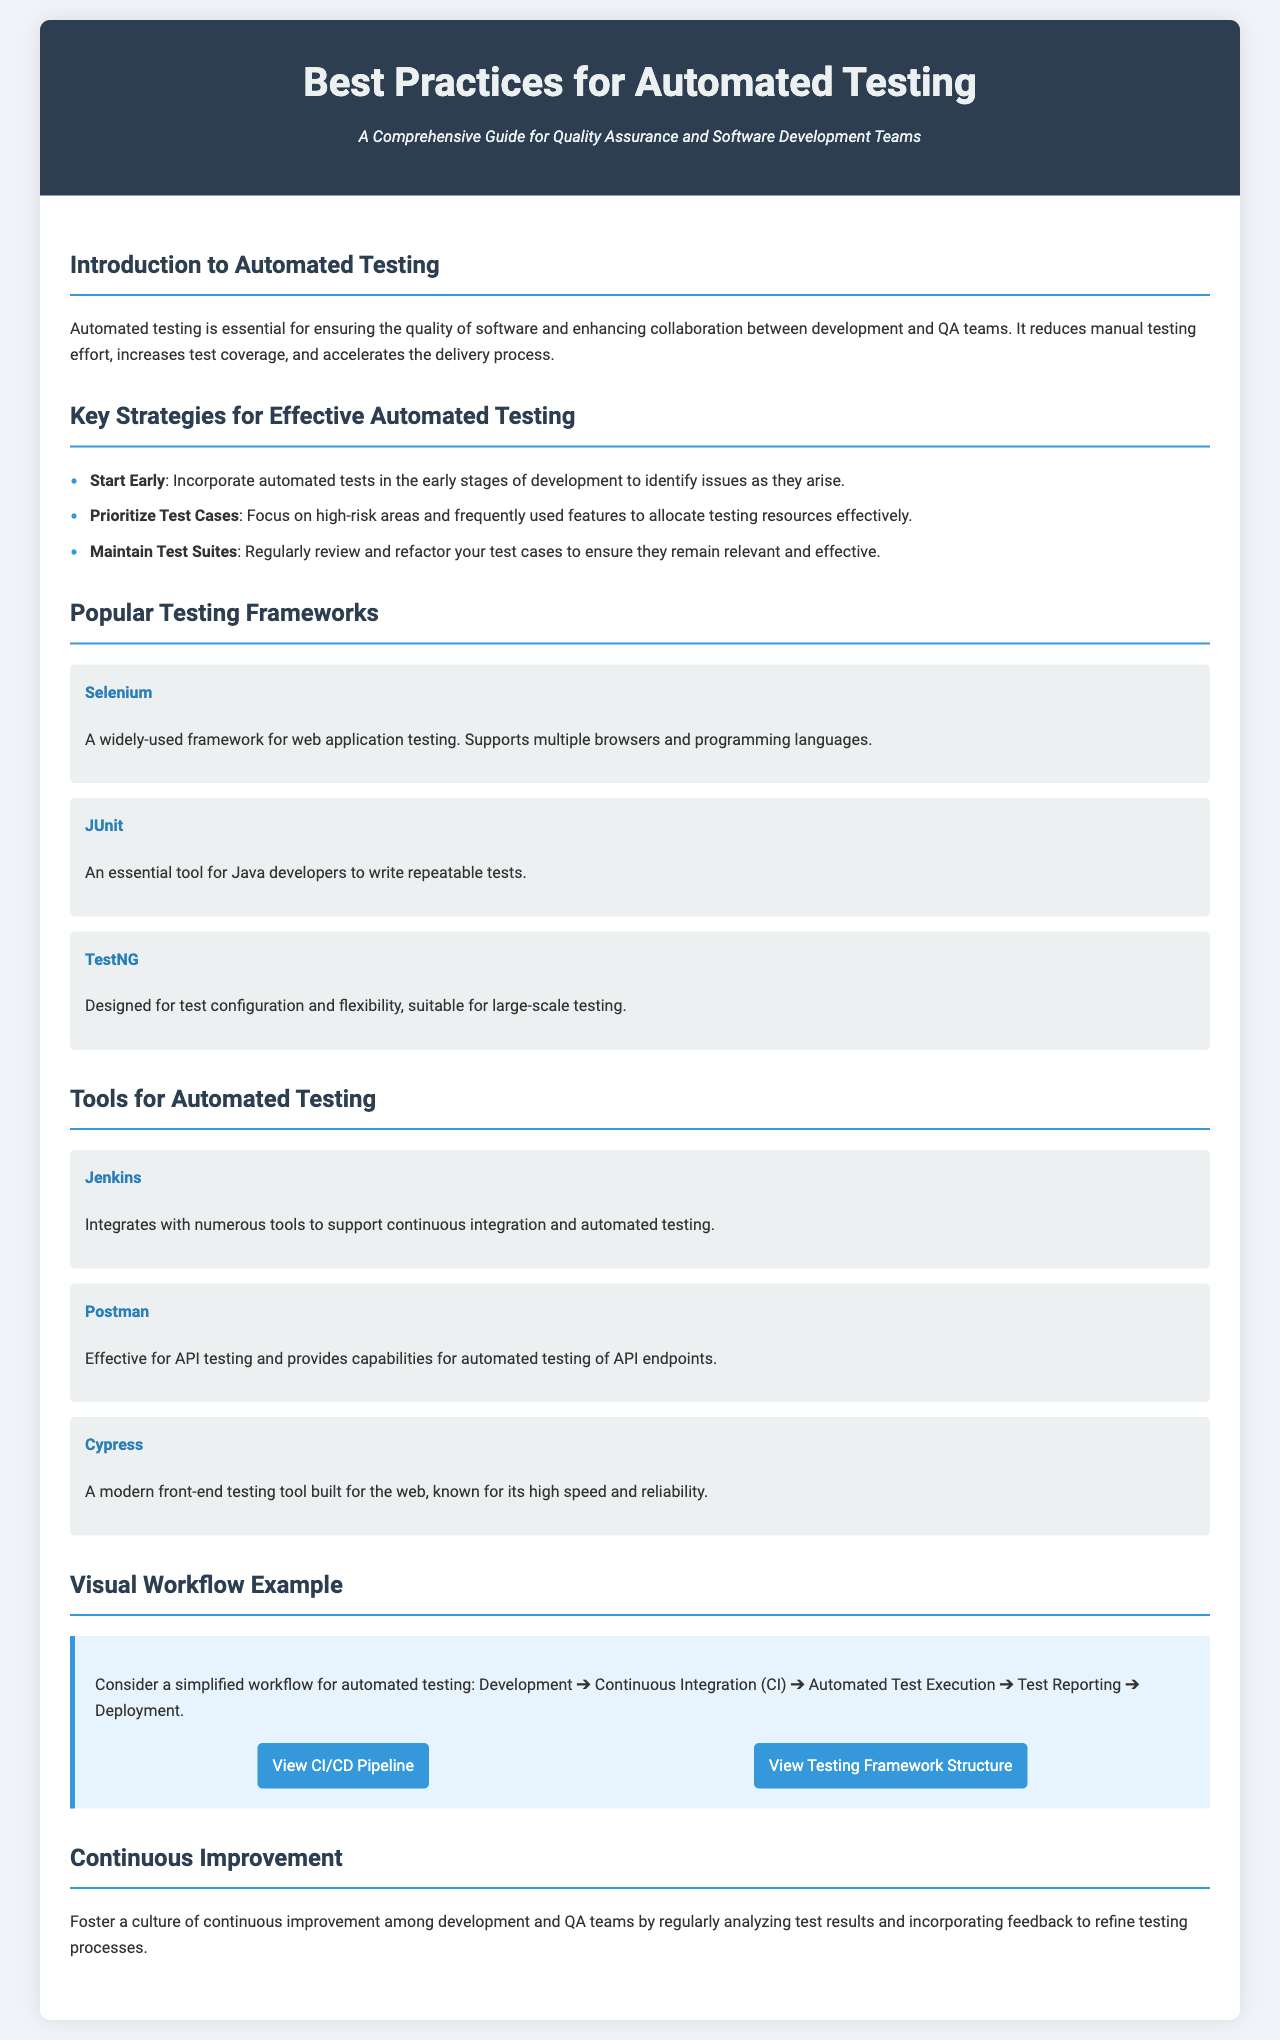What is the subtitle of the brochure? The subtitle provides additional context about the document, specifically mentioning its focus on quality assurance and software development teams.
Answer: A Comprehensive Guide for Quality Assurance and Software Development Teams What is the first strategy mentioned for effective automated testing? It is the first listed item under key strategies, highlighting its importance in the testing process.
Answer: Start Early Which testing framework is described as widely-used for web application testing? This framework is specifically mentioned among popular testing frameworks and is known for its broad support.
Answer: Selenium How many tools are listed for automated testing? The document enumerates the tools provided in a section dedicated to such tools.
Answer: Three What is the final section titled in the brochure? The section title indicates a focus on ongoing improvements in testing practices.
Answer: Continuous Improvement What is the visual workflow example presented in the document? The workflow illustrates the sequence of steps in the automated testing process.
Answer: Development ➔ Continuous Integration (CI) ➔ Automated Test Execution ➔ Test Reporting ➔ Deployment Which tool is known for its capabilities in API testing? This tool is specifically mentioned for its effectiveness in testing API endpoints among the tools listed.
Answer: Postman What color is used for the header background? The header's color is crucial for the visual appeal of the document and is mentioned directly in the design specifications.
Answer: Dark Blue 